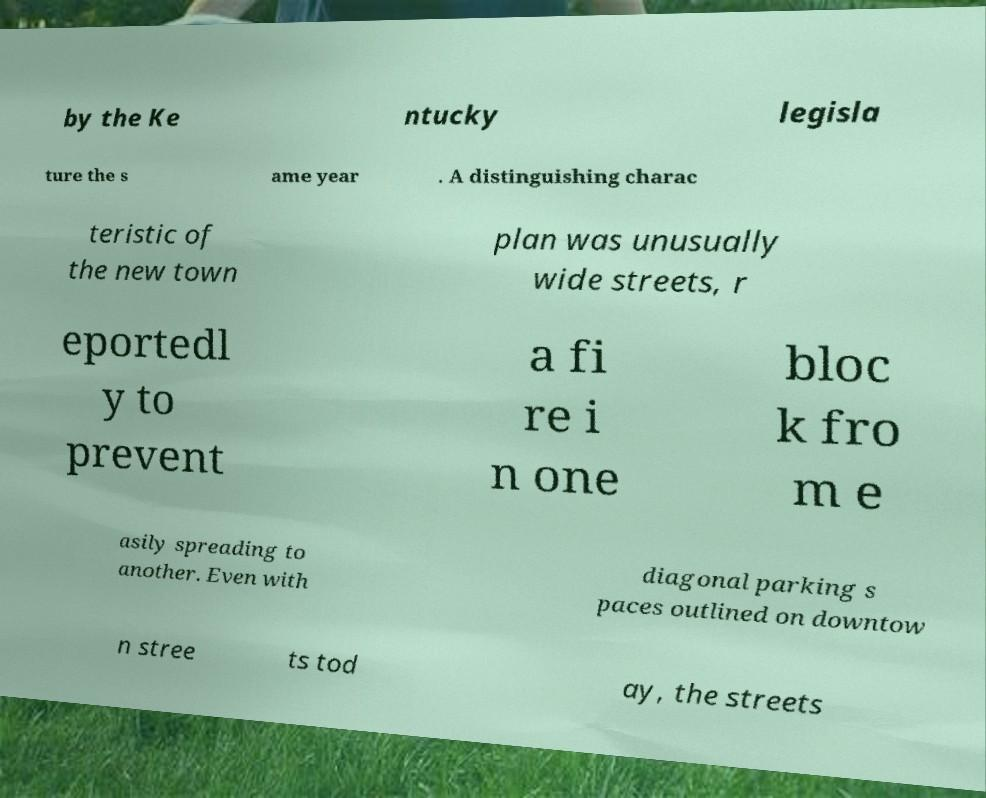Can you read and provide the text displayed in the image?This photo seems to have some interesting text. Can you extract and type it out for me? by the Ke ntucky legisla ture the s ame year . A distinguishing charac teristic of the new town plan was unusually wide streets, r eportedl y to prevent a fi re i n one bloc k fro m e asily spreading to another. Even with diagonal parking s paces outlined on downtow n stree ts tod ay, the streets 